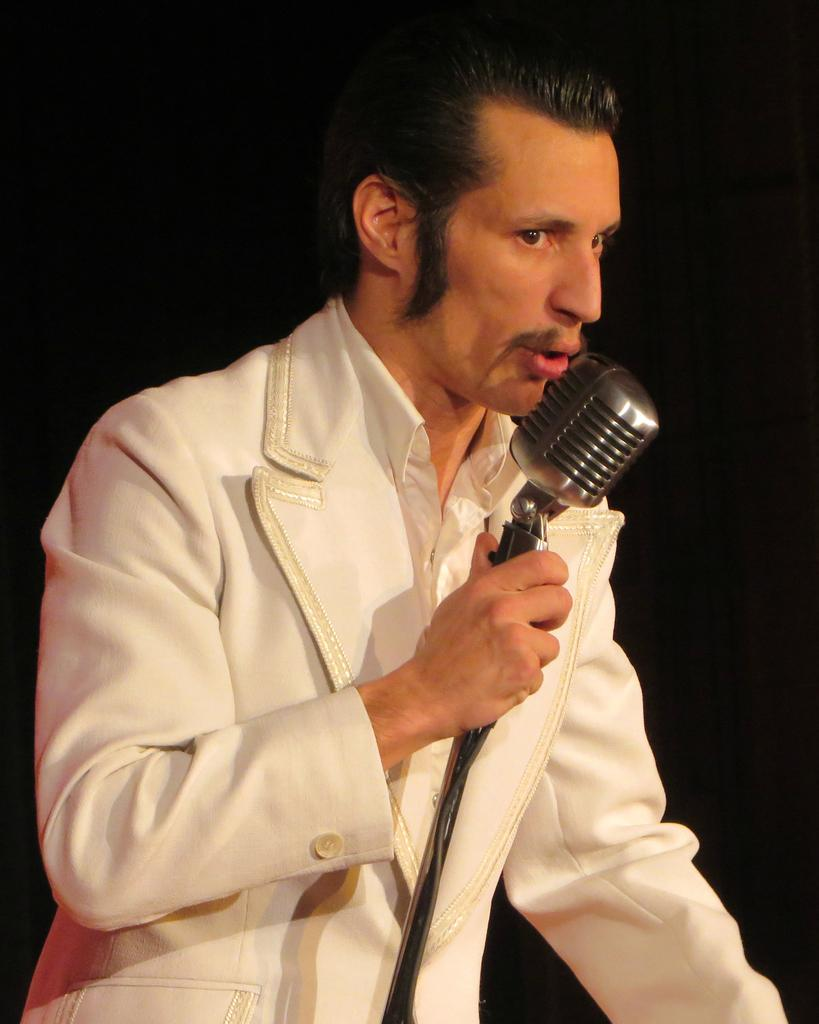Who is the main subject in the image? There is a man in the image. What is the man wearing? The man is wearing a white coat. What object is the man holding? The man is holding a microphone. What action is the man performing? The man's mouth is open, suggesting he is singing. What type of grape is the man holding in the image? There is no grape present in the image; the man is holding a microphone. What color is the chalk the man is using to write love messages in the image? There is no chalk or love messages present in the image; the man is holding a microphone and appears to be singing. 